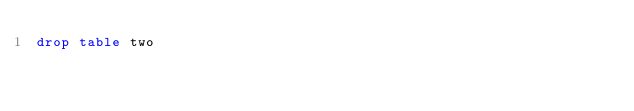<code> <loc_0><loc_0><loc_500><loc_500><_SQL_>drop table two</code> 